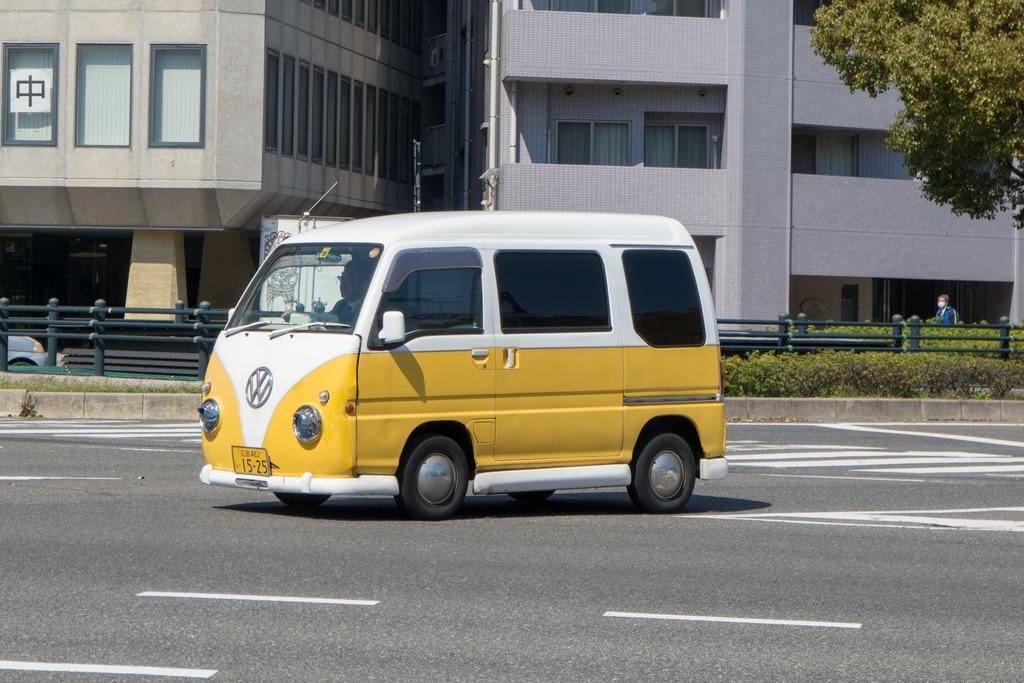What is the main subject in the middle of the image? There is a vehicle on the road in the image, and it is in the middle of the image. What can be seen on the right side of the image? There are plants and a tree on the right side of the image. What is visible in the background of the image? There are buildings visible in the background of the image. Can you see any children swimming in the image? There are no children or swimming activity present in the image. 